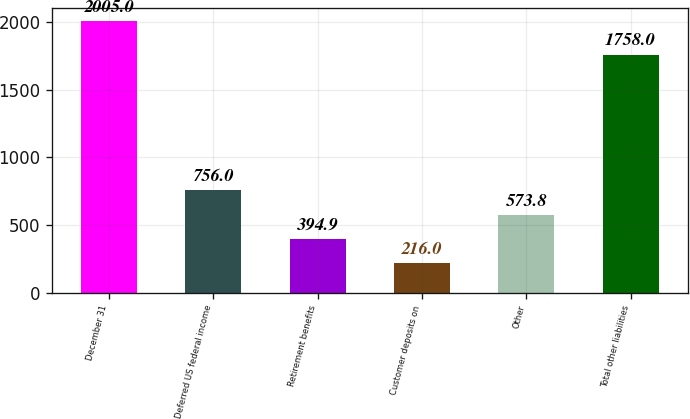<chart> <loc_0><loc_0><loc_500><loc_500><bar_chart><fcel>December 31<fcel>Deferred US federal income<fcel>Retirement benefits<fcel>Customer deposits on<fcel>Other<fcel>Total other liabilities<nl><fcel>2005<fcel>756<fcel>394.9<fcel>216<fcel>573.8<fcel>1758<nl></chart> 